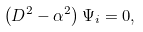<formula> <loc_0><loc_0><loc_500><loc_500>\left ( D ^ { 2 } - \alpha ^ { 2 } \right ) \Psi _ { i } = 0 ,</formula> 